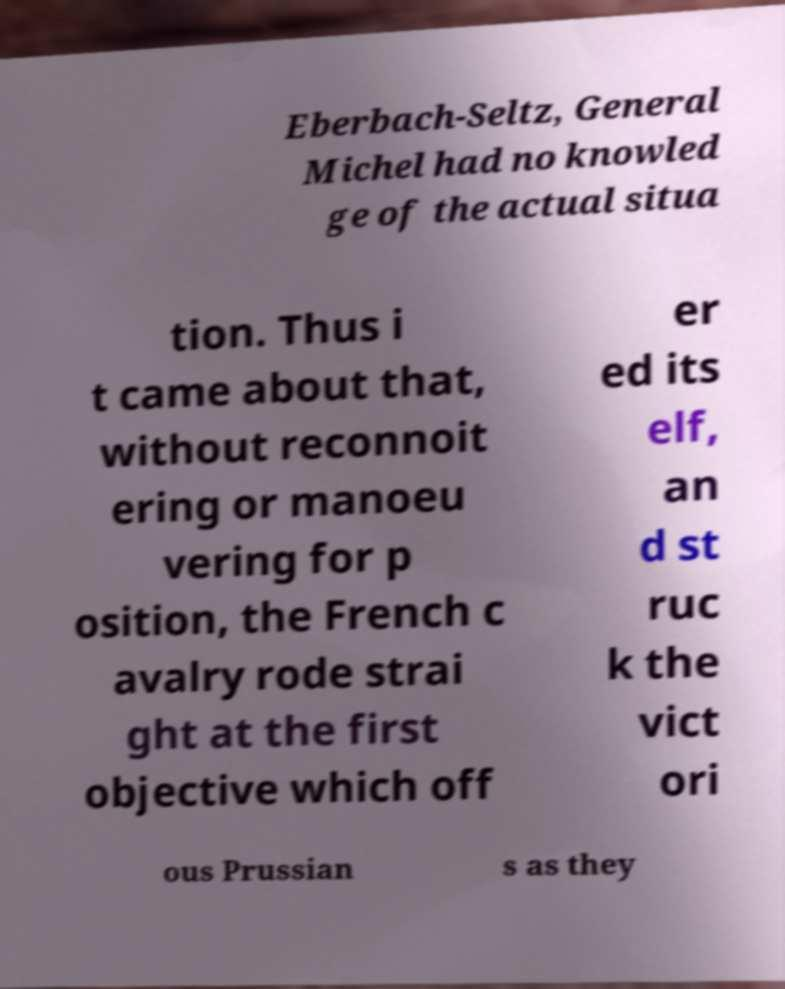Please identify and transcribe the text found in this image. Eberbach-Seltz, General Michel had no knowled ge of the actual situa tion. Thus i t came about that, without reconnoit ering or manoeu vering for p osition, the French c avalry rode strai ght at the first objective which off er ed its elf, an d st ruc k the vict ori ous Prussian s as they 